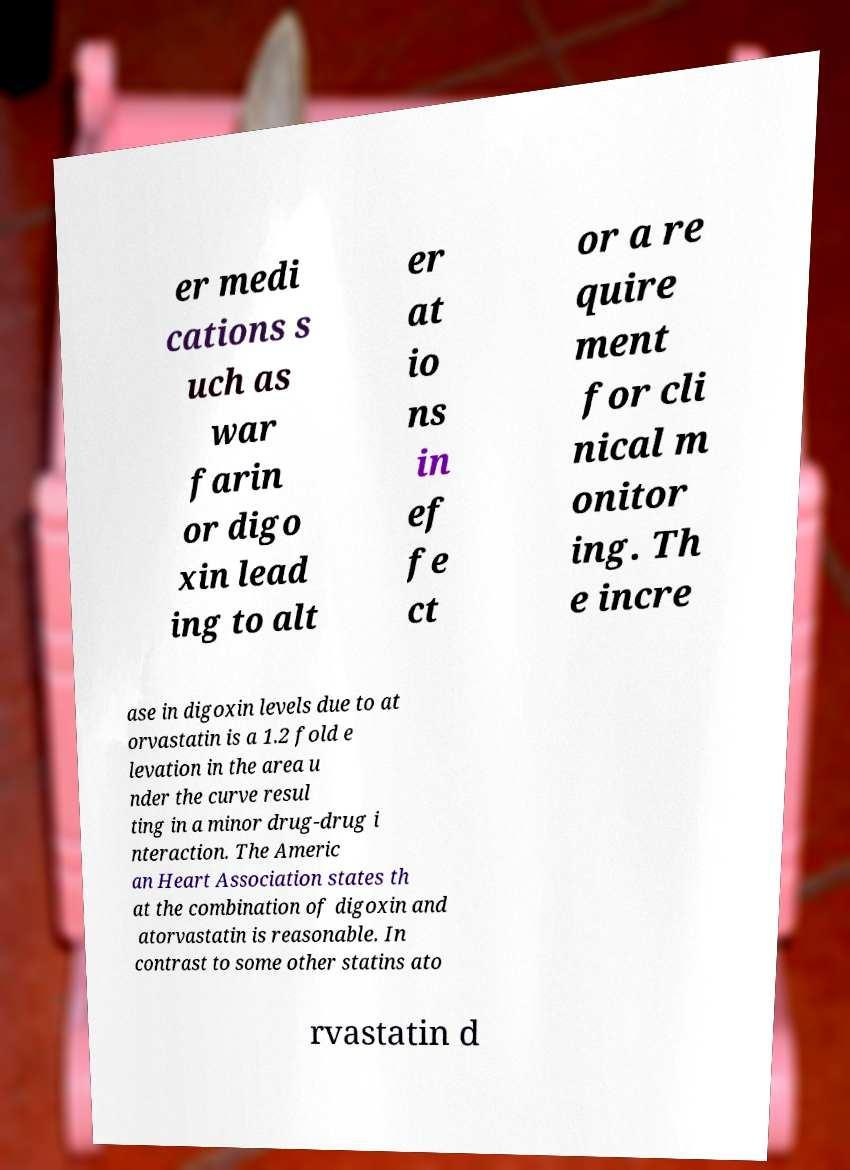What messages or text are displayed in this image? I need them in a readable, typed format. er medi cations s uch as war farin or digo xin lead ing to alt er at io ns in ef fe ct or a re quire ment for cli nical m onitor ing. Th e incre ase in digoxin levels due to at orvastatin is a 1.2 fold e levation in the area u nder the curve resul ting in a minor drug-drug i nteraction. The Americ an Heart Association states th at the combination of digoxin and atorvastatin is reasonable. In contrast to some other statins ato rvastatin d 